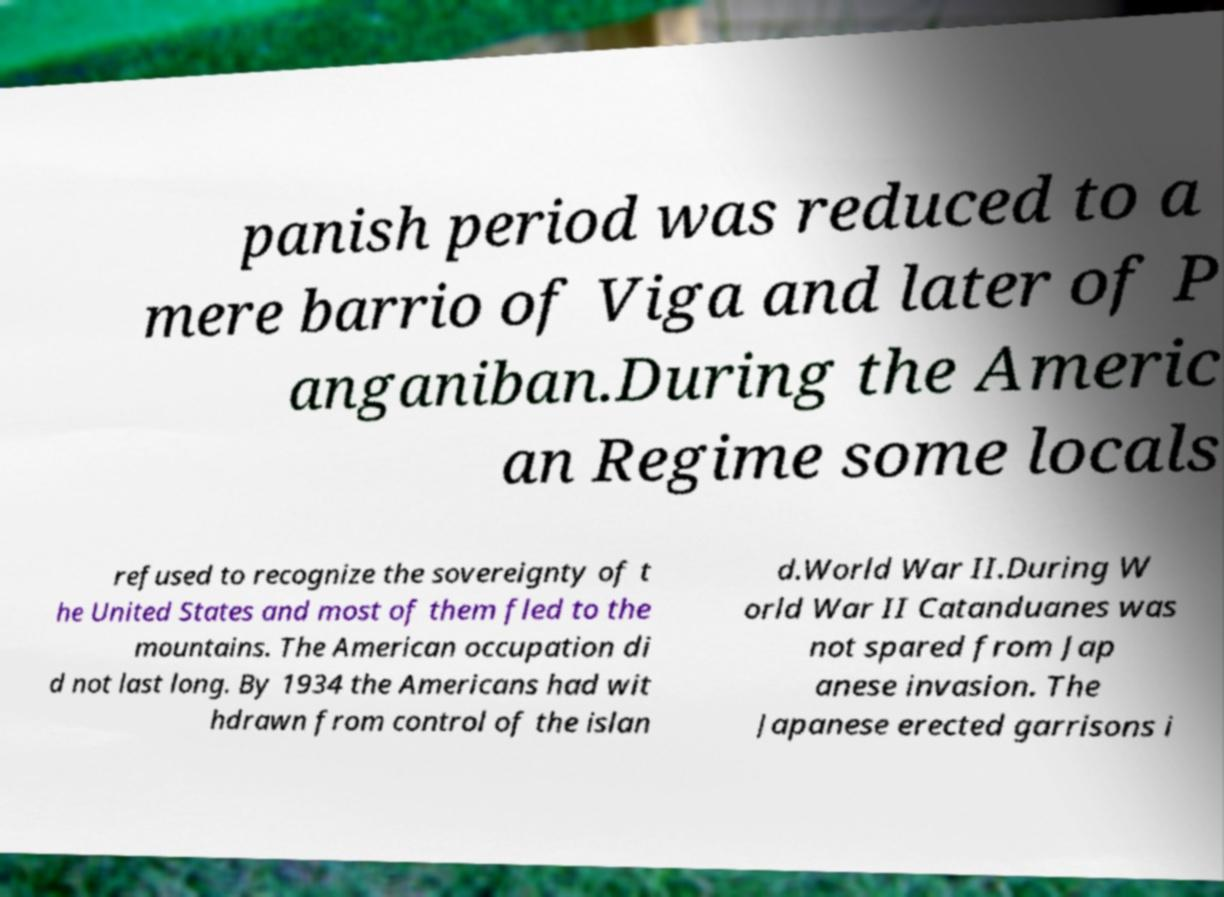Please read and relay the text visible in this image. What does it say? panish period was reduced to a mere barrio of Viga and later of P anganiban.During the Americ an Regime some locals refused to recognize the sovereignty of t he United States and most of them fled to the mountains. The American occupation di d not last long. By 1934 the Americans had wit hdrawn from control of the islan d.World War II.During W orld War II Catanduanes was not spared from Jap anese invasion. The Japanese erected garrisons i 